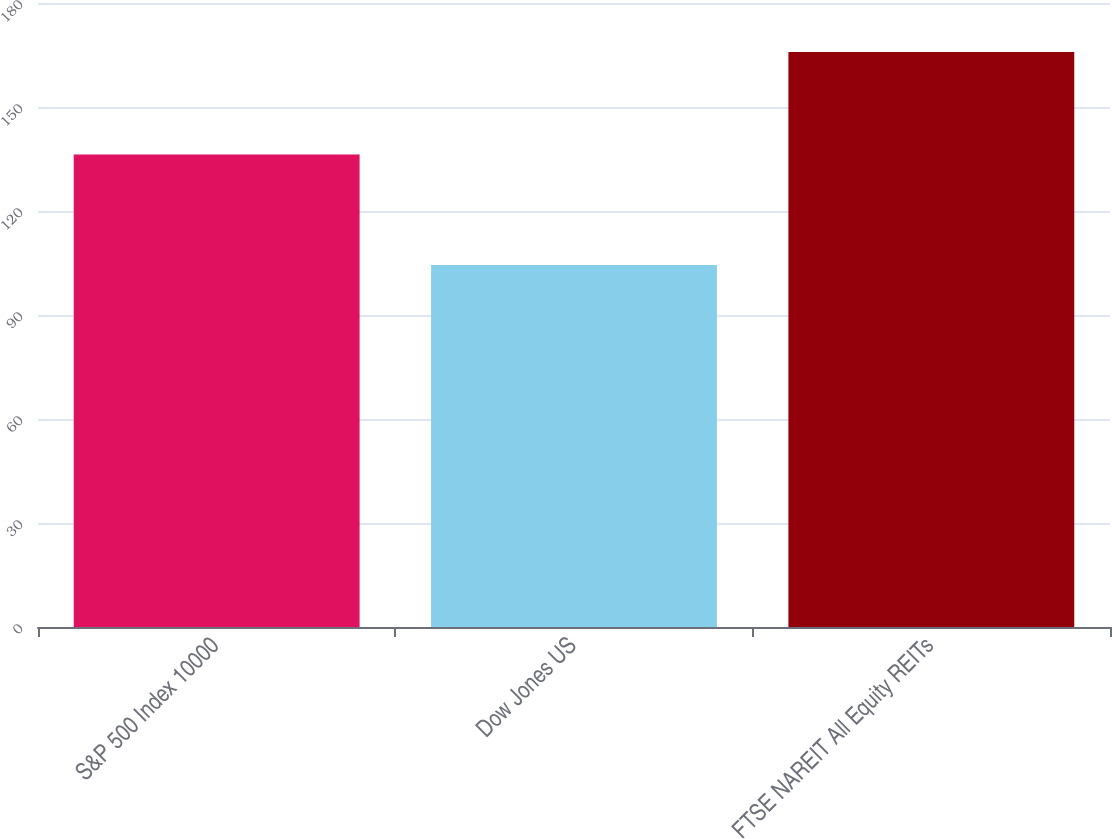<chart> <loc_0><loc_0><loc_500><loc_500><bar_chart><fcel>S&P 500 Index 10000<fcel>Dow Jones US<fcel>FTSE NAREIT All Equity REITs<nl><fcel>136.3<fcel>104.42<fcel>165.84<nl></chart> 